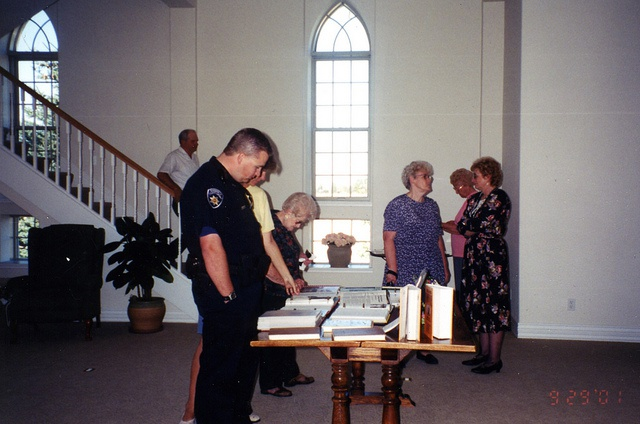Describe the objects in this image and their specific colors. I can see people in black, brown, maroon, and salmon tones, chair in black and gray tones, people in black, maroon, gray, and brown tones, people in black, navy, purple, and brown tones, and potted plant in black, maroon, gray, and navy tones in this image. 